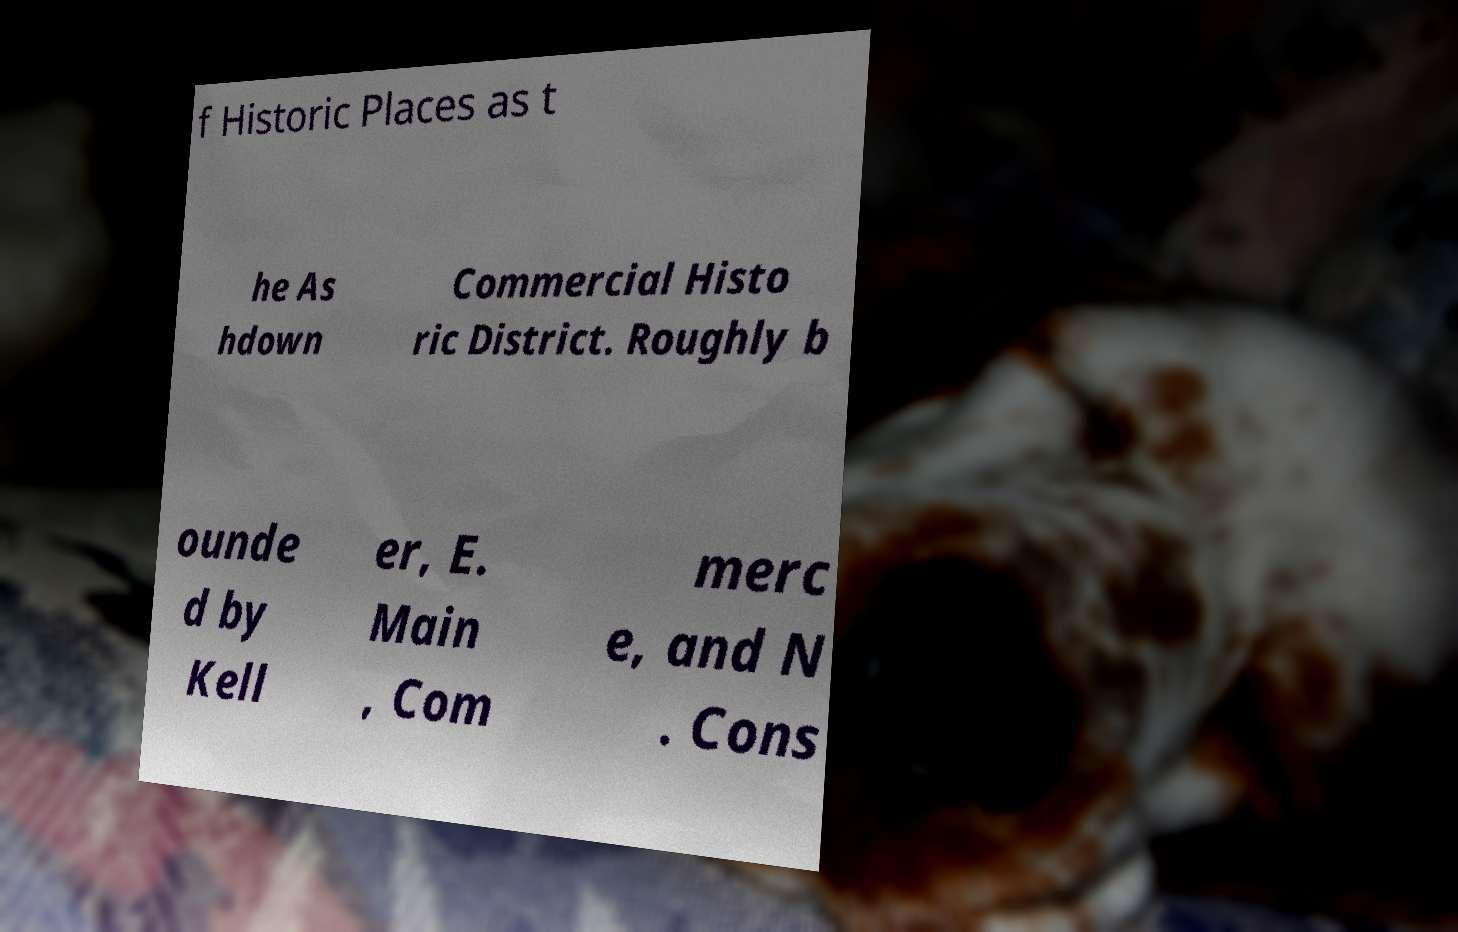There's text embedded in this image that I need extracted. Can you transcribe it verbatim? f Historic Places as t he As hdown Commercial Histo ric District. Roughly b ounde d by Kell er, E. Main , Com merc e, and N . Cons 